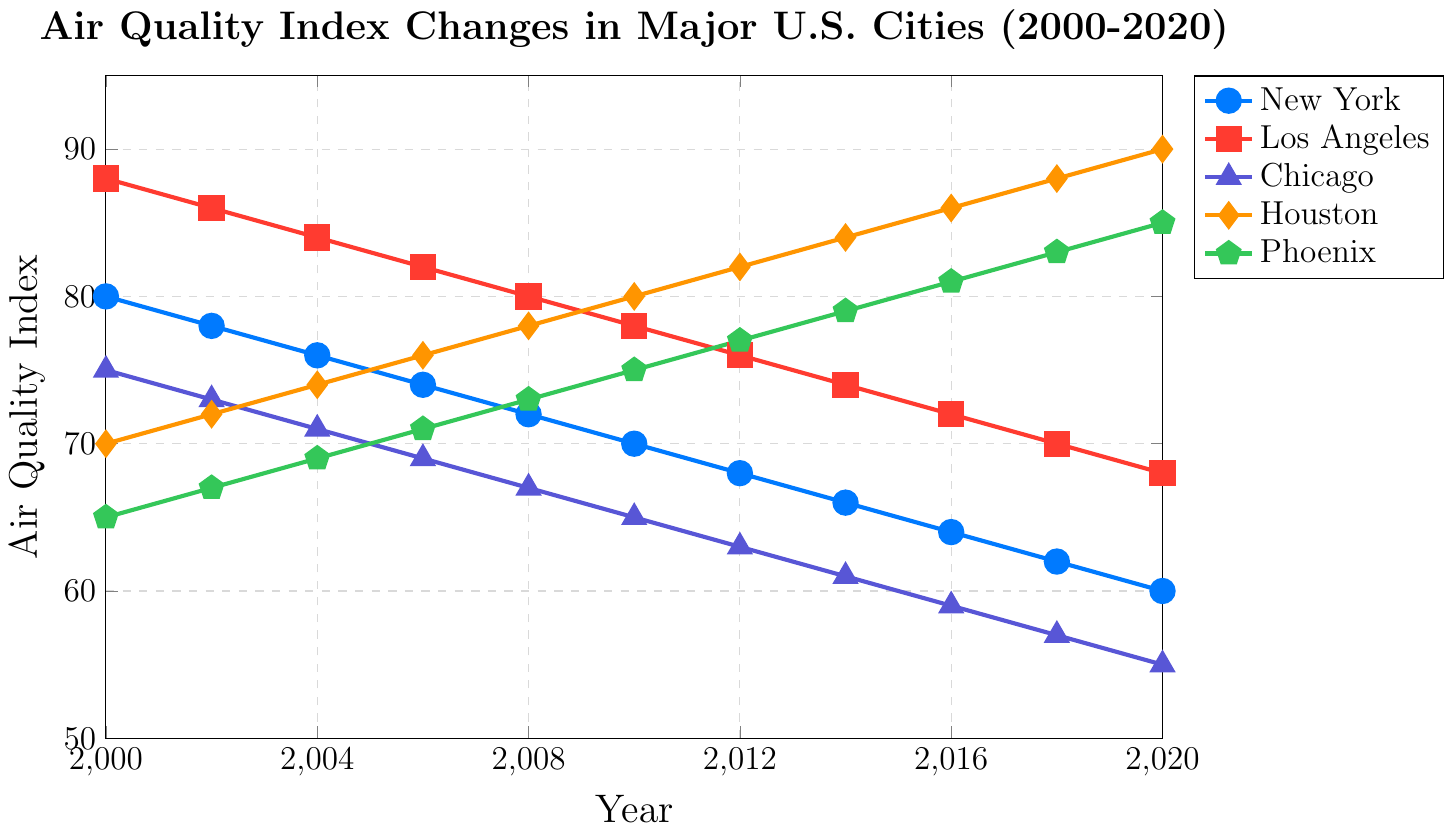What's the overall trend for New York's Air Quality Index from 2000 to 2020? The plot shows a consistent decrease in the Air Quality Index for New York, starting at 80 in 2000 and dropping to 60 by 2020
Answer: decreasing Which city had the highest Air Quality Index in 2020? From the plot, the highest Air Quality Index in 2020 belongs to Houston with a value of 90
Answer: Houston Between which years did Los Angeles see the largest decrease in Air Quality Index? Observing the plot, Los Angeles saw a consistent but the largest visual drop appears between 2000 and 2002, from 88 to 86
Answer: 2000-2002 In which year was Phoenix's Air Quality Index first above 80? From the plot, Phoenix's Air Quality Index first surpassed 80 in the year 2016
Answer: 2016 Compare the Air Quality Index of Chicago and Houston in 2008. Which city had a worse index and by how much? In 2008, Chicago had an Air Quality Index of 67, while Houston had 78. To find the difference, subtract 67 from 78
Answer: Houston by 11 What is the average Air Quality Index for New York between 2000 and 2020? Adding up the values for New York from 2000 to 2020 (80, 78, 76, 74, 72, 70, 68, 66, 64, 62, 60) gives 770. Dividing by the number of years (11) gives the average 770/11
Answer: 70 Compare the Air Quality Index trends of Phoenix and Chicago from 2000 to 2020. How are they different? Visually, Phoenix's Air Quality Index is increasing steadily over the years, whereas Chicago's index is decreasing.
Answer: Phoenix (increasing), Chicago (decreasing) In which year did Houston's Air Quality Index reach 80? According to the plot, Houston's Air Quality Index reached exactly 80 in the year 2010
Answer: 2010 What is the median Air Quality Index of Los Angeles from 2000 to 2020? The values for Los Angeles are (88, 86, 84, 82, 80, 78, 76, 74, 72, 70, 68). To find the median, arrange them in order (68, 70, 72, 74, 76, 78, 80, 82, 84, 86, 88), the middle value is 78
Answer: 78 